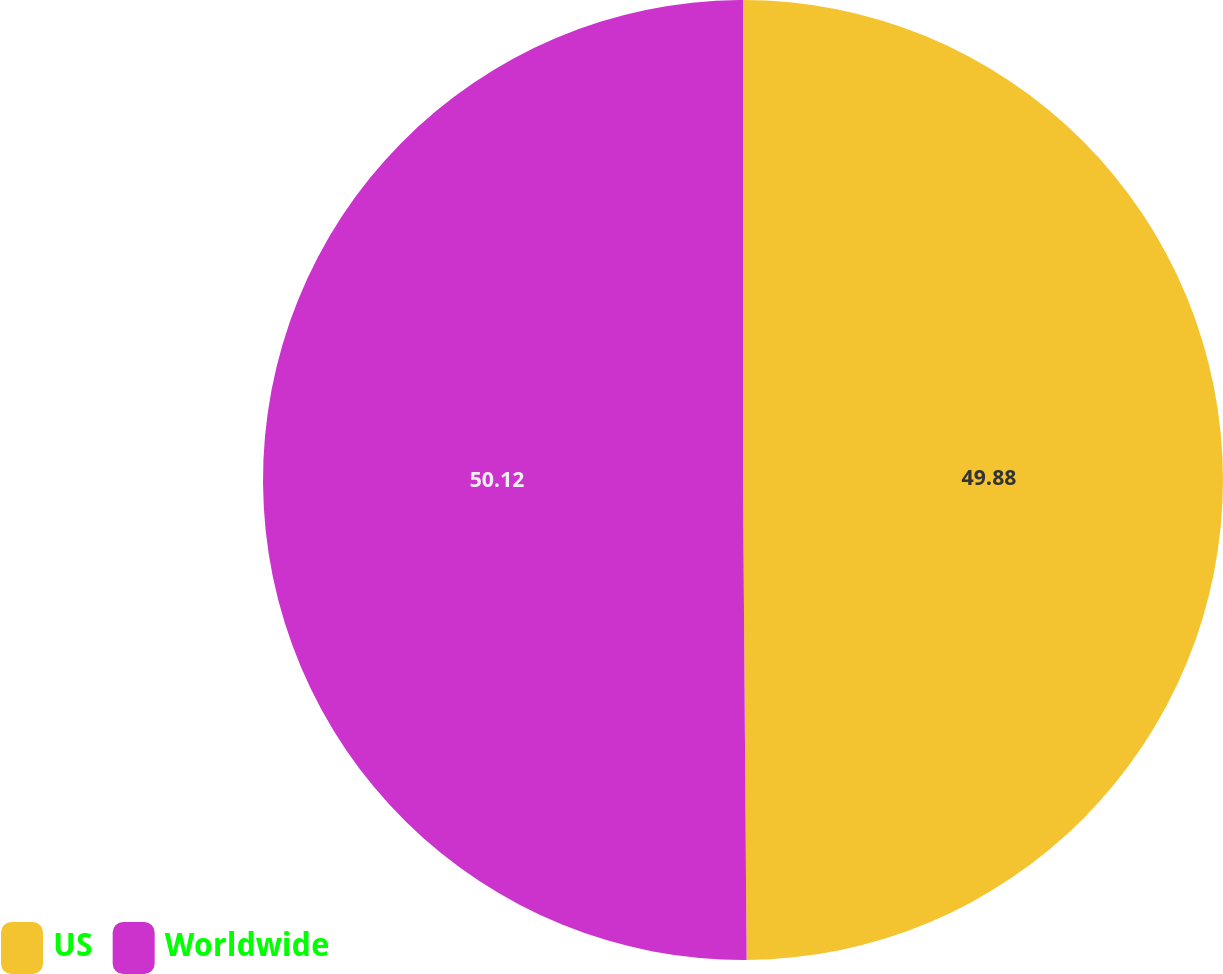<chart> <loc_0><loc_0><loc_500><loc_500><pie_chart><fcel>US<fcel>Worldwide<nl><fcel>49.88%<fcel>50.12%<nl></chart> 